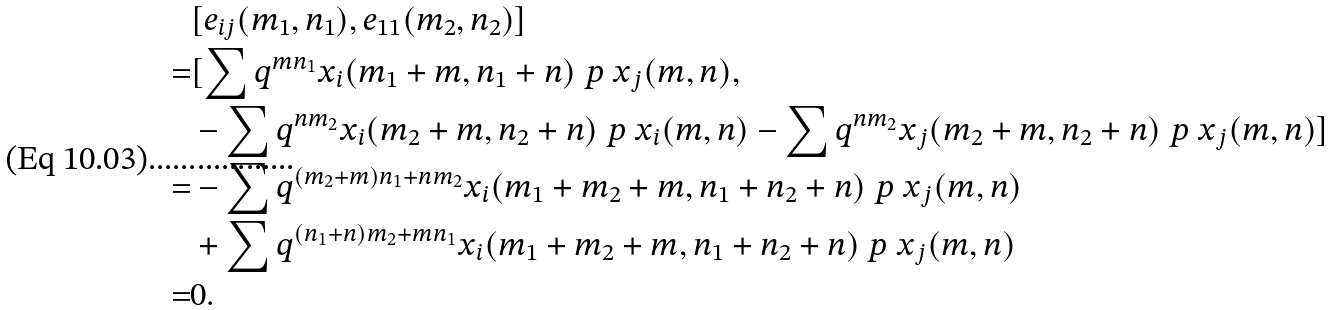<formula> <loc_0><loc_0><loc_500><loc_500>& [ e _ { i j } ( m _ { 1 } , n _ { 1 } ) , e _ { 1 1 } ( m _ { 2 } , n _ { 2 } ) ] \\ = & [ \sum q ^ { m n _ { 1 } } x _ { i } ( m _ { 1 } + m , n _ { 1 } + n ) \ p { \ x _ { j } ( m , n ) } , \\ & - \sum q ^ { n m _ { 2 } } x _ { i } ( m _ { 2 } + m , n _ { 2 } + n ) \ p { \ x _ { i } ( m , n ) } - \sum q ^ { n m _ { 2 } } x _ { j } ( m _ { 2 } + m , n _ { 2 } + n ) \ p { \ x _ { j } ( m , n ) } ] \\ = & - \sum q ^ { ( m _ { 2 } + m ) n _ { 1 } + n m _ { 2 } } x _ { i } ( m _ { 1 } + m _ { 2 } + m , n _ { 1 } + n _ { 2 } + n ) \ p { \ x _ { j } ( m , n ) } \\ & + \sum q ^ { ( n _ { 1 } + n ) m _ { 2 } + m n _ { 1 } } x _ { i } ( m _ { 1 } + m _ { 2 } + m , n _ { 1 } + n _ { 2 } + n ) \ p { \ x _ { j } ( m , n ) } \\ = & 0 .</formula> 